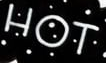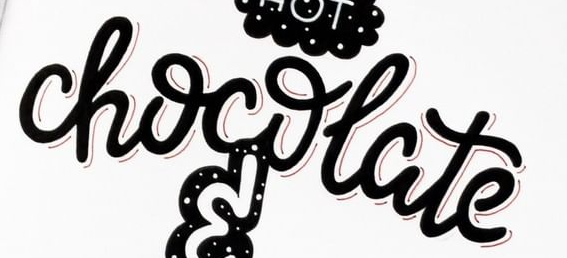Read the text from these images in sequence, separated by a semicolon. HOT; chocolate 